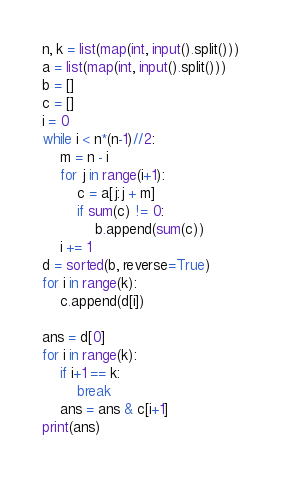<code> <loc_0><loc_0><loc_500><loc_500><_Python_>n, k = list(map(int, input().split()))
a = list(map(int, input().split()))
b = []
c = []
i = 0
while i < n*(n-1)//2:
    m = n - i
    for j in range(i+1):
        c = a[j:j + m]
        if sum(c) != 0:
            b.append(sum(c))
    i += 1
d = sorted(b, reverse=True)
for i in range(k):
    c.append(d[i])

ans = d[0]
for i in range(k):
    if i+1 == k:
        break
    ans = ans & c[i+1]
print(ans)</code> 